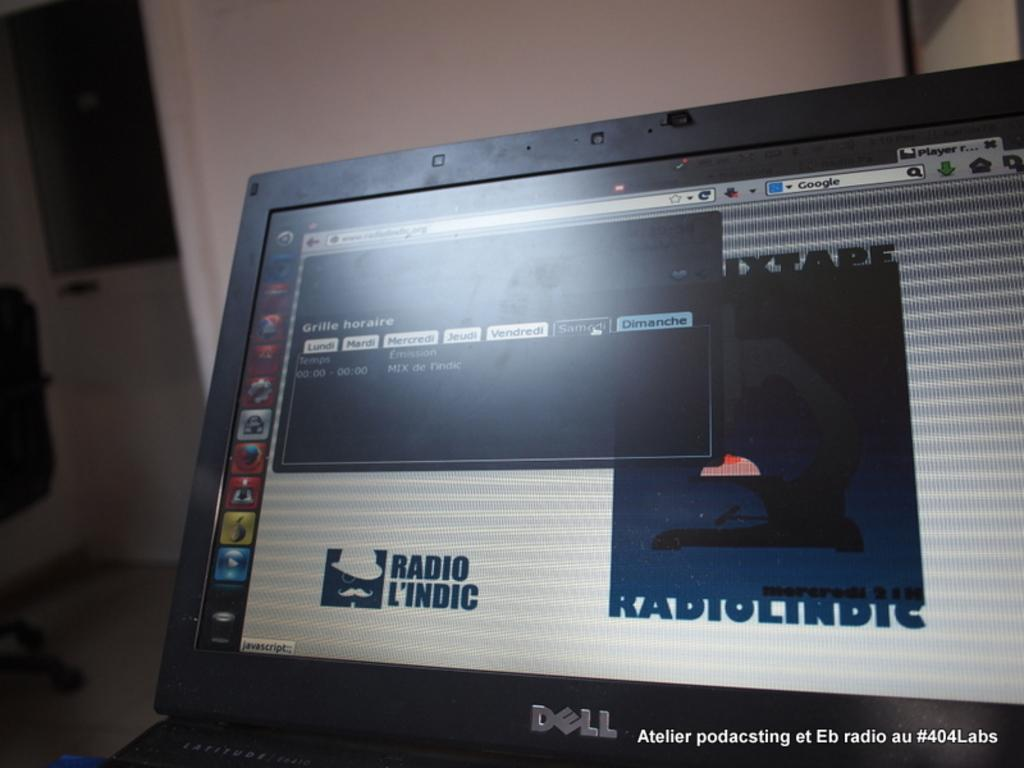<image>
Create a compact narrative representing the image presented. A laptop computer made by dell that is on a website about radios. 